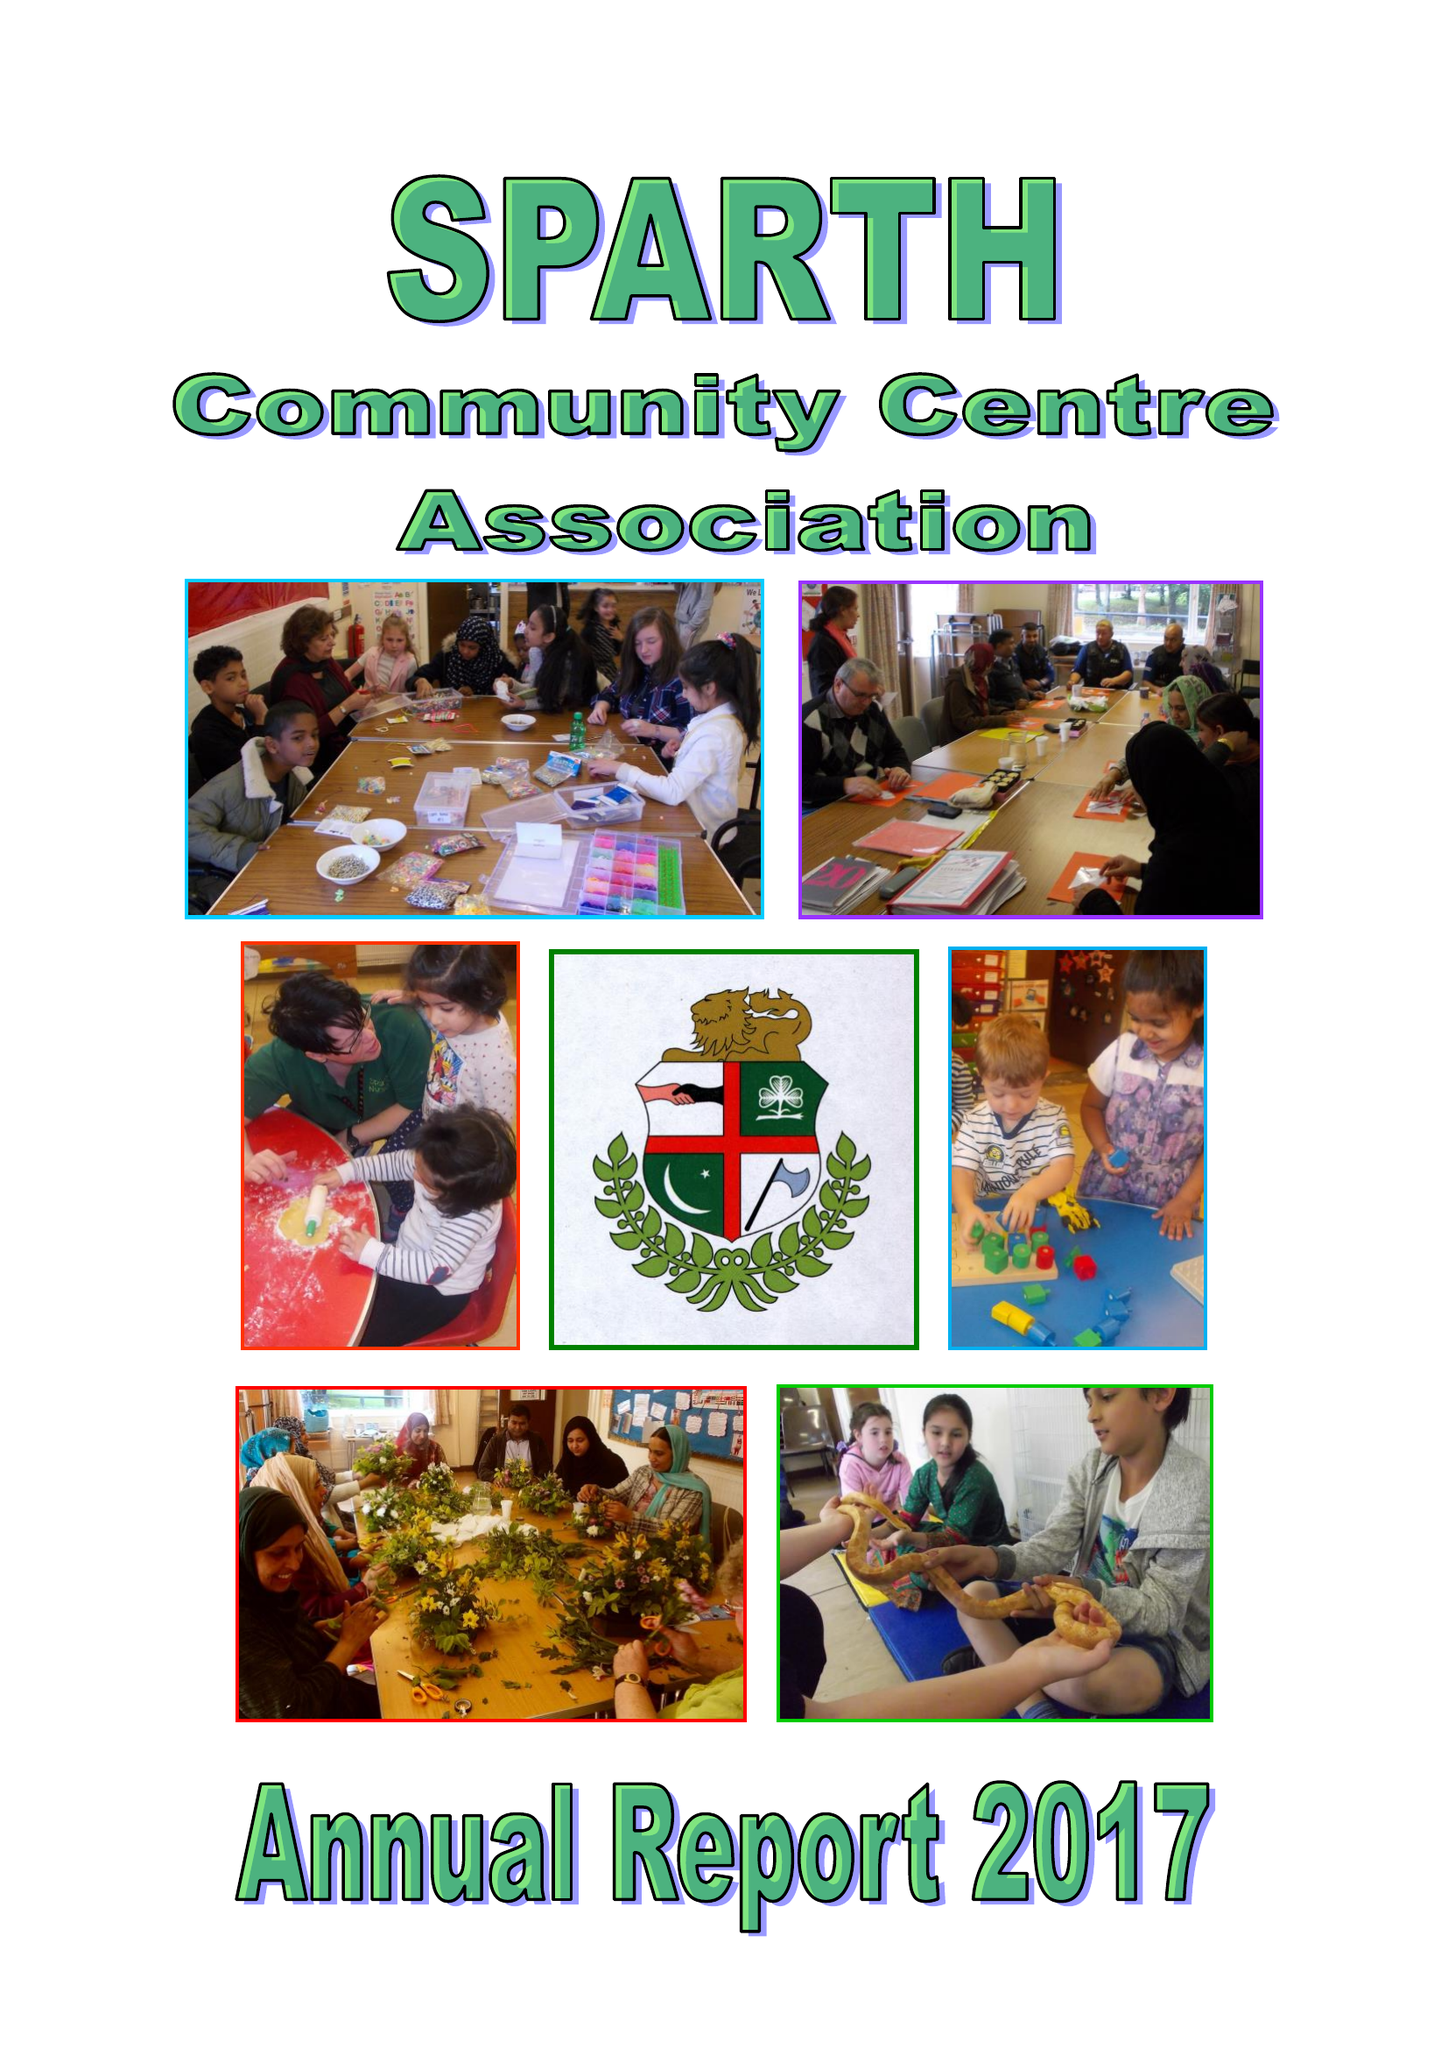What is the value for the spending_annually_in_british_pounds?
Answer the question using a single word or phrase. 98485.00 